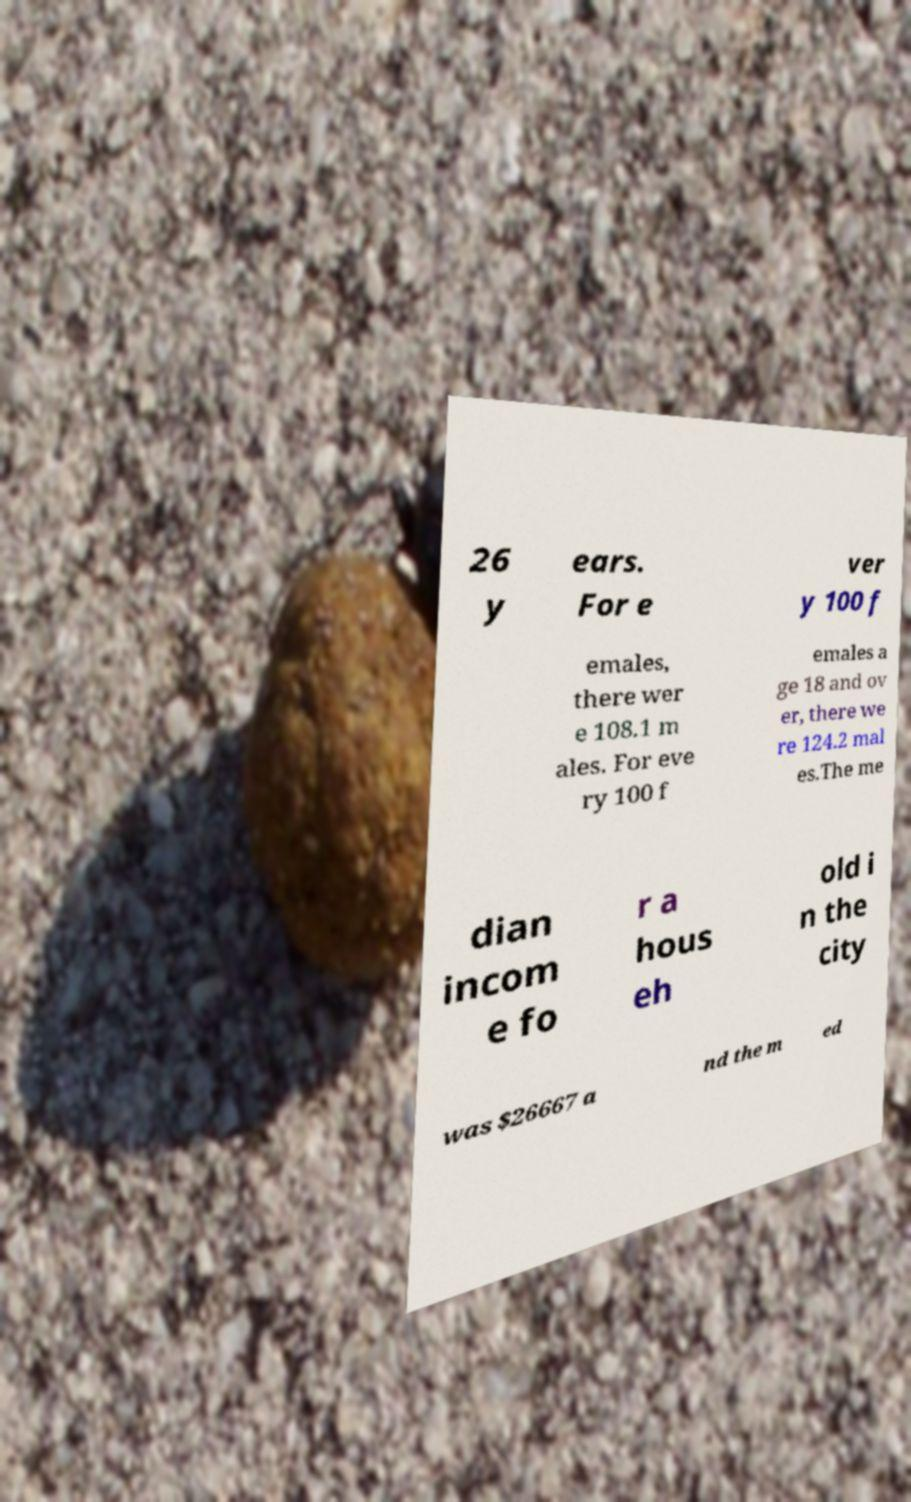For documentation purposes, I need the text within this image transcribed. Could you provide that? 26 y ears. For e ver y 100 f emales, there wer e 108.1 m ales. For eve ry 100 f emales a ge 18 and ov er, there we re 124.2 mal es.The me dian incom e fo r a hous eh old i n the city was $26667 a nd the m ed 